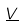Convert formula to latex. <formula><loc_0><loc_0><loc_500><loc_500>\underline { V }</formula> 